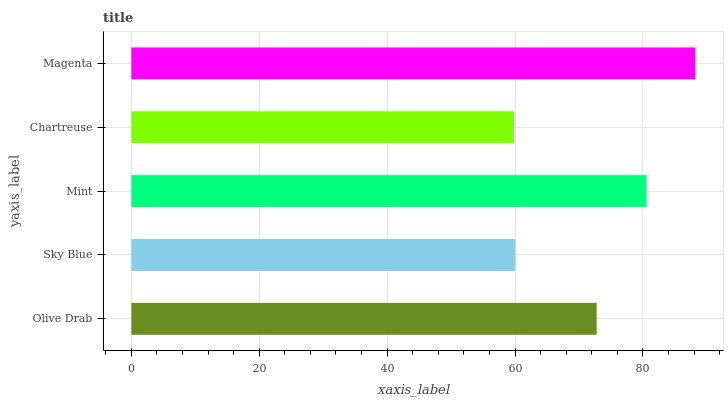Is Chartreuse the minimum?
Answer yes or no. Yes. Is Magenta the maximum?
Answer yes or no. Yes. Is Sky Blue the minimum?
Answer yes or no. No. Is Sky Blue the maximum?
Answer yes or no. No. Is Olive Drab greater than Sky Blue?
Answer yes or no. Yes. Is Sky Blue less than Olive Drab?
Answer yes or no. Yes. Is Sky Blue greater than Olive Drab?
Answer yes or no. No. Is Olive Drab less than Sky Blue?
Answer yes or no. No. Is Olive Drab the high median?
Answer yes or no. Yes. Is Olive Drab the low median?
Answer yes or no. Yes. Is Sky Blue the high median?
Answer yes or no. No. Is Mint the low median?
Answer yes or no. No. 